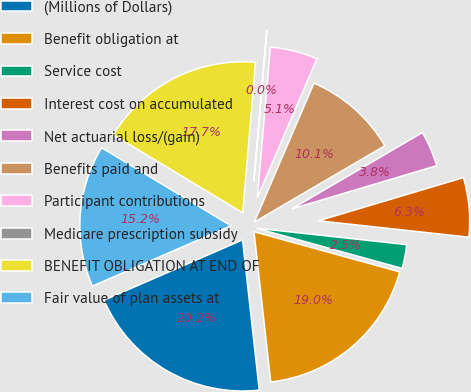Convert chart. <chart><loc_0><loc_0><loc_500><loc_500><pie_chart><fcel>(Millions of Dollars)<fcel>Benefit obligation at<fcel>Service cost<fcel>Interest cost on accumulated<fcel>Net actuarial loss/(gain)<fcel>Benefits paid and<fcel>Participant contributions<fcel>Medicare prescription subsidy<fcel>BENEFIT OBLIGATION AT END OF<fcel>Fair value of plan assets at<nl><fcel>20.23%<fcel>18.96%<fcel>2.55%<fcel>6.34%<fcel>3.81%<fcel>10.13%<fcel>5.08%<fcel>0.03%<fcel>17.7%<fcel>15.18%<nl></chart> 